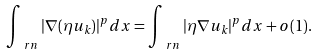Convert formula to latex. <formula><loc_0><loc_0><loc_500><loc_500>\int _ { \ r n } | \nabla ( \eta u _ { k } ) | ^ { p } d x = \int _ { \ r n } | \eta \nabla u _ { k } | ^ { p } d x + o ( 1 ) .</formula> 